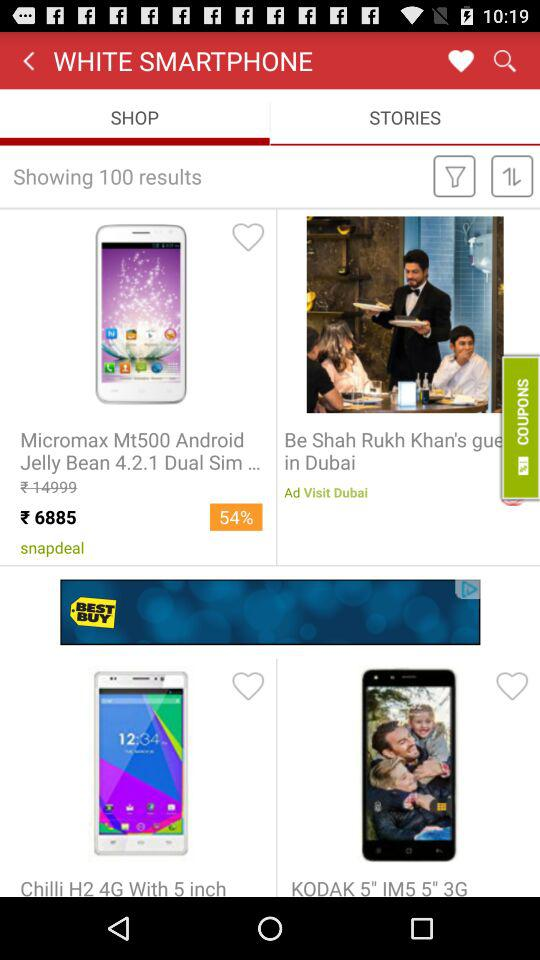What is the cost of the "Micromax Mt500 Android Jelly Bean 4.2.1 Dual Sim..."? The cost is Rs. 6885. 